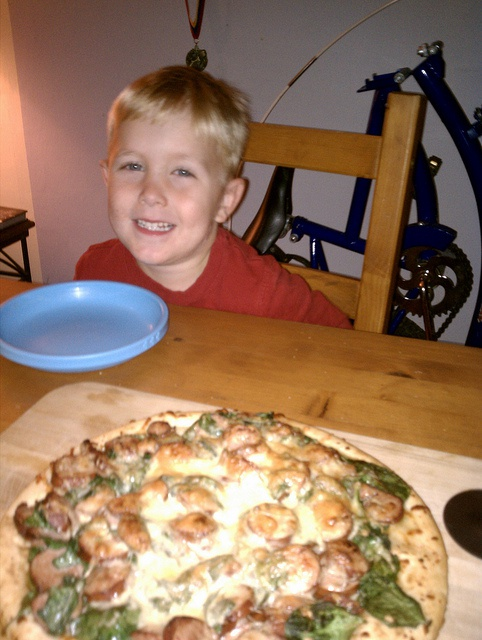Describe the objects in this image and their specific colors. I can see dining table in brown and tan tones, pizza in brown, tan, and beige tones, people in brown, lightpink, gray, and maroon tones, chair in brown, black, maroon, and gray tones, and bicycle in brown, black, gray, and maroon tones in this image. 